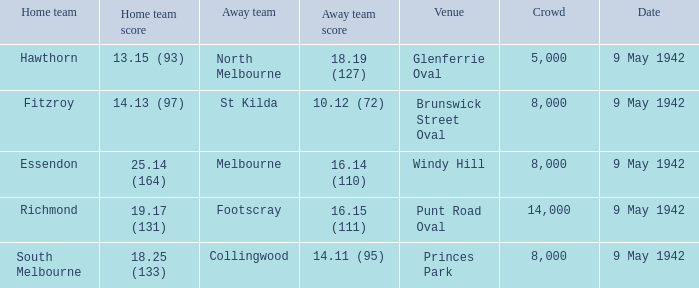How many spectators were at the event where footscray played away? 14000.0. Could you parse the entire table? {'header': ['Home team', 'Home team score', 'Away team', 'Away team score', 'Venue', 'Crowd', 'Date'], 'rows': [['Hawthorn', '13.15 (93)', 'North Melbourne', '18.19 (127)', 'Glenferrie Oval', '5,000', '9 May 1942'], ['Fitzroy', '14.13 (97)', 'St Kilda', '10.12 (72)', 'Brunswick Street Oval', '8,000', '9 May 1942'], ['Essendon', '25.14 (164)', 'Melbourne', '16.14 (110)', 'Windy Hill', '8,000', '9 May 1942'], ['Richmond', '19.17 (131)', 'Footscray', '16.15 (111)', 'Punt Road Oval', '14,000', '9 May 1942'], ['South Melbourne', '18.25 (133)', 'Collingwood', '14.11 (95)', 'Princes Park', '8,000', '9 May 1942']]} 